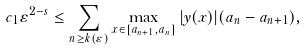<formula> <loc_0><loc_0><loc_500><loc_500>c _ { 1 } \varepsilon ^ { 2 - s } \leq \sum _ { n \geq k ( \varepsilon ) } \max _ { x \in [ a _ { n + 1 } , a _ { n } ] } | y ( x ) | ( a _ { n } - a _ { n + 1 } ) ,</formula> 